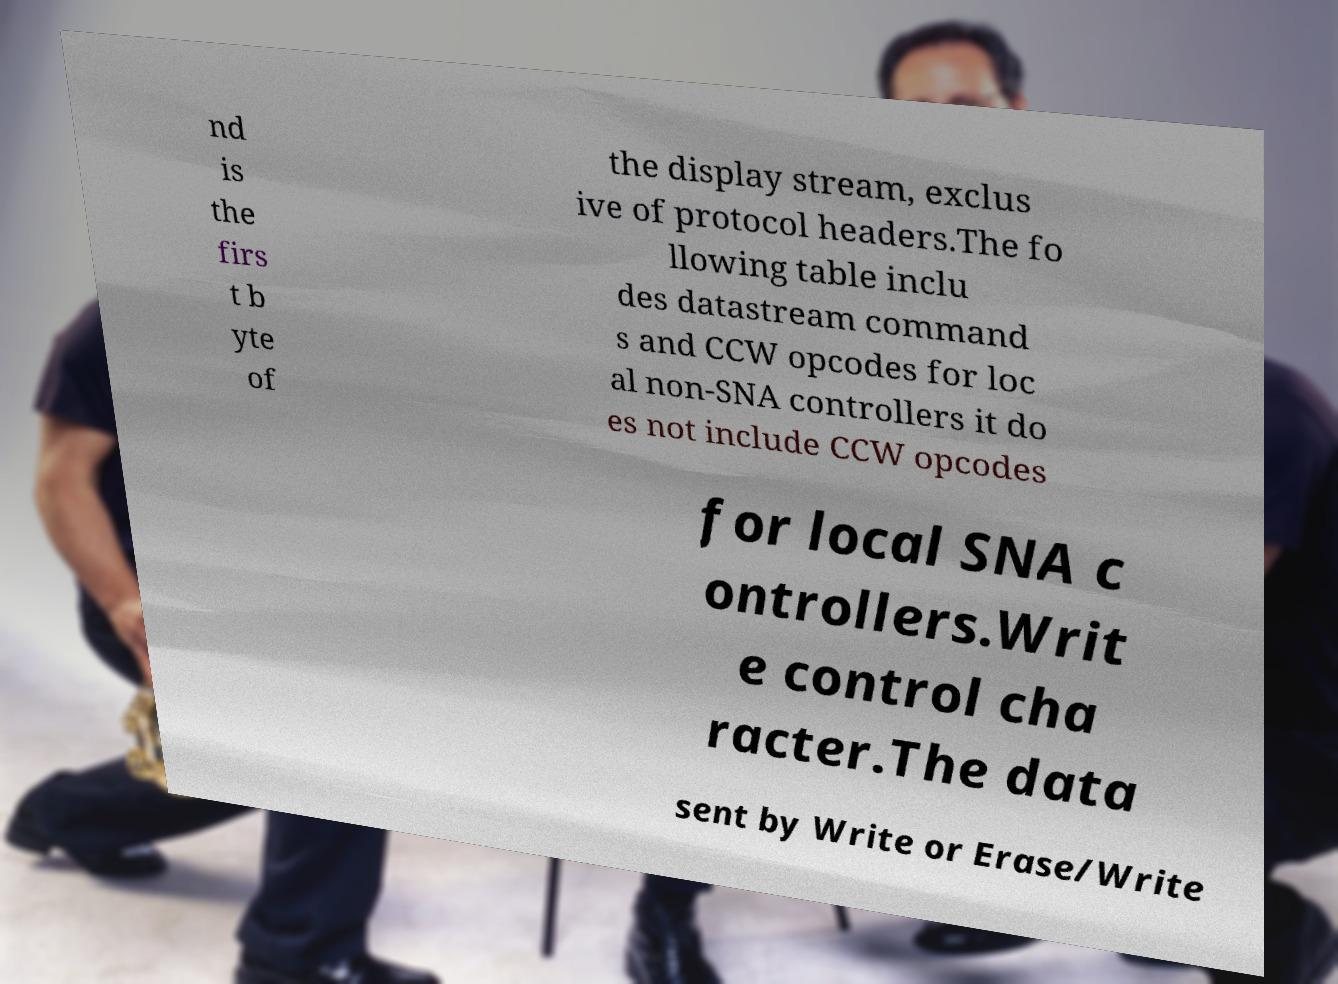Please identify and transcribe the text found in this image. nd is the firs t b yte of the display stream, exclus ive of protocol headers.The fo llowing table inclu des datastream command s and CCW opcodes for loc al non-SNA controllers it do es not include CCW opcodes for local SNA c ontrollers.Writ e control cha racter.The data sent by Write or Erase/Write 